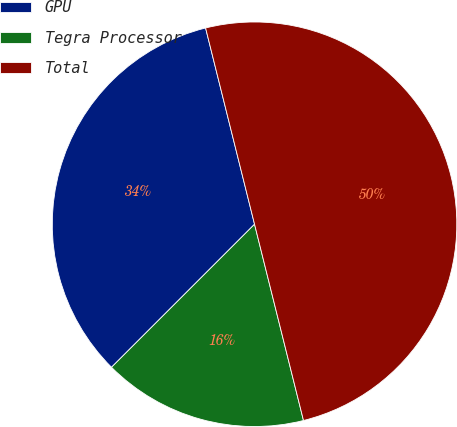Convert chart to OTSL. <chart><loc_0><loc_0><loc_500><loc_500><pie_chart><fcel>GPU<fcel>Tegra Processor<fcel>Total<nl><fcel>33.61%<fcel>16.39%<fcel>50.0%<nl></chart> 